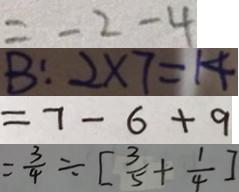<formula> <loc_0><loc_0><loc_500><loc_500>= - 2 - 4 
 B : 2 \times 7 = 1 4 
 = 7 - 6 + 9 
 = \frac { 3 } { 4 } \div [ \frac { 3 } { 5 } + \frac { 1 } { 4 } ]</formula> 